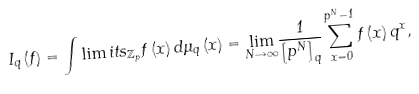Convert formula to latex. <formula><loc_0><loc_0><loc_500><loc_500>I _ { q } \left ( f \right ) = \int \lim i t s _ { \mathbb { Z } _ { p } } f \left ( x \right ) d \mu _ { q } \left ( x \right ) = \underset { N \rightarrow \infty } { \lim } \frac { 1 } { \left [ p ^ { N } \right ] _ { q } } \sum _ { x = 0 } ^ { p ^ { N } - 1 } f \left ( x \right ) q ^ { x } ,</formula> 